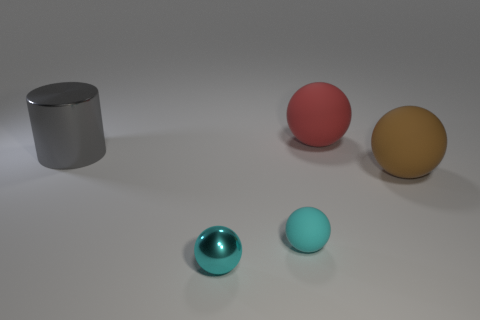Subtract all large red rubber spheres. How many spheres are left? 3 Subtract all cyan balls. How many balls are left? 2 Subtract 1 balls. How many balls are left? 3 Subtract all red cylinders. Subtract all gray spheres. How many cylinders are left? 1 Subtract all green blocks. How many cyan spheres are left? 2 Subtract all red rubber spheres. Subtract all tiny rubber balls. How many objects are left? 3 Add 5 matte spheres. How many matte spheres are left? 8 Add 5 small rubber spheres. How many small rubber spheres exist? 6 Add 5 red objects. How many objects exist? 10 Subtract 0 blue balls. How many objects are left? 5 